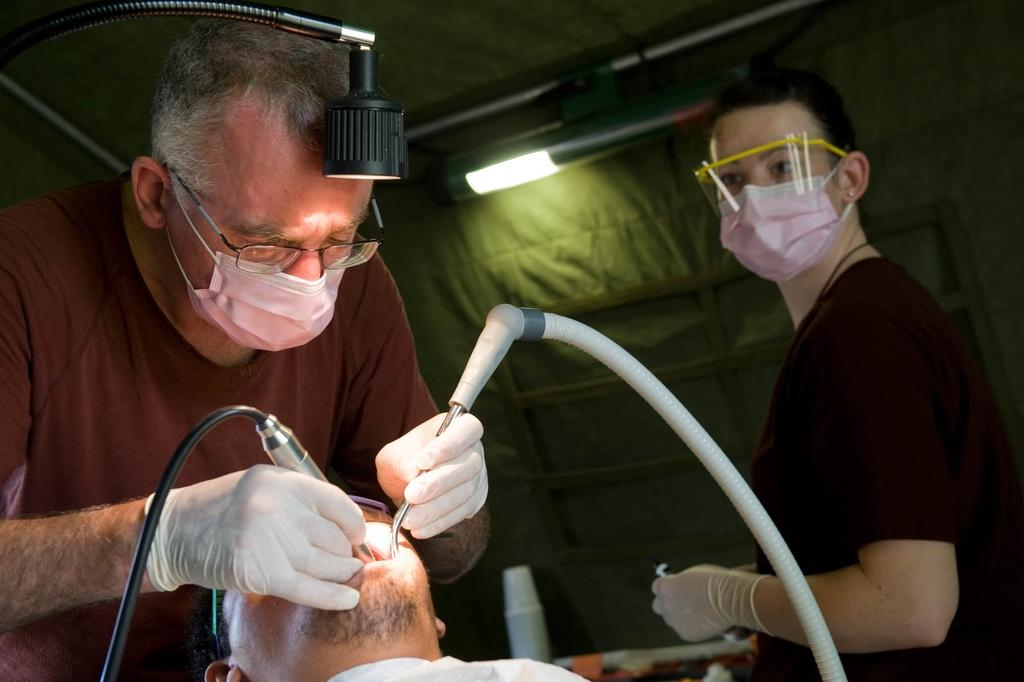What is the person on the right side of the image wearing? The person is wearing a mask. What is the person on the right side of the image holding? The person is holding an object. Can you describe the woman on the right side of the image? The woman is also wearing a mask. What type of crayon is the person using to draw on the wall in the image? There is no crayon or drawing on the wall present in the image. 